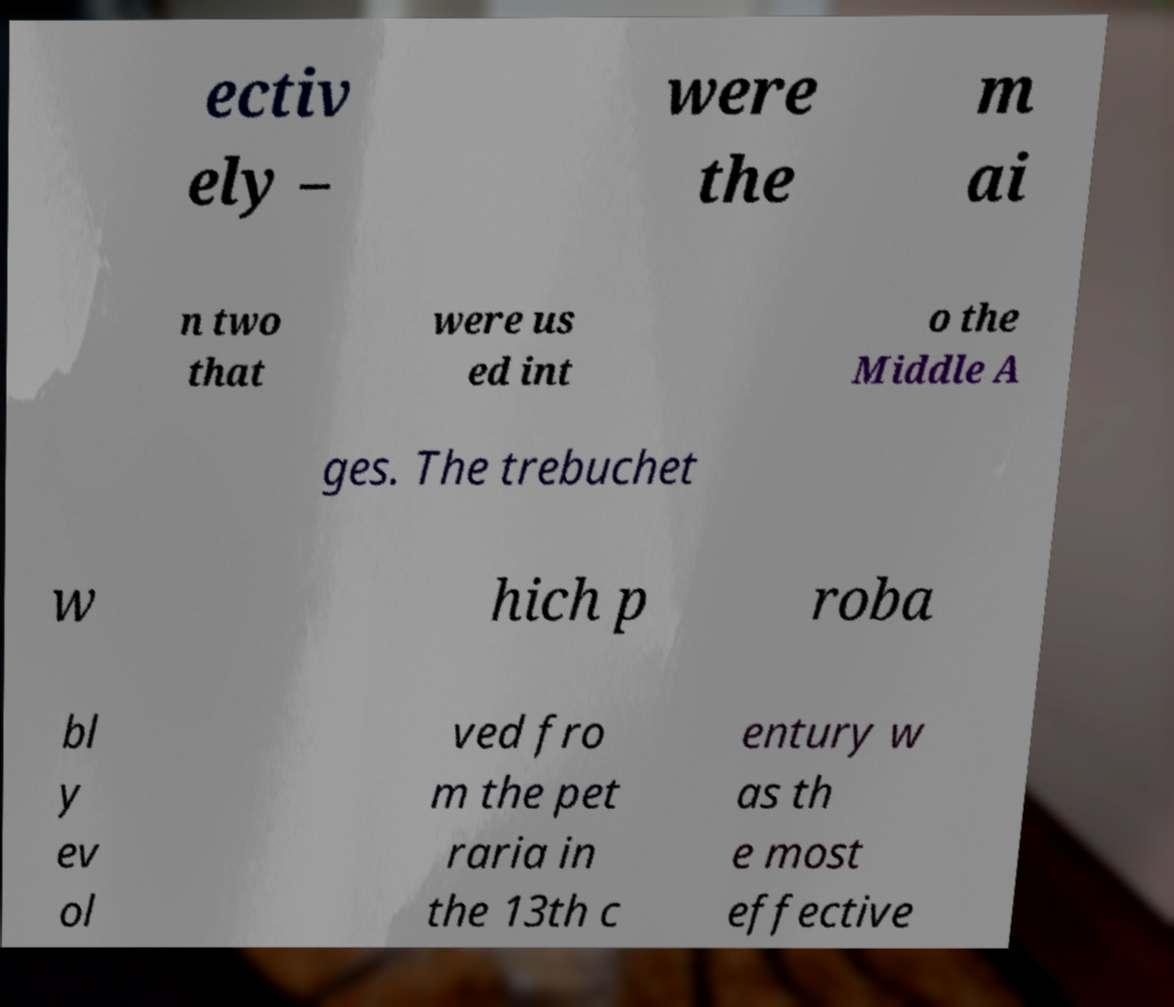Can you read and provide the text displayed in the image?This photo seems to have some interesting text. Can you extract and type it out for me? ectiv ely – were the m ai n two that were us ed int o the Middle A ges. The trebuchet w hich p roba bl y ev ol ved fro m the pet raria in the 13th c entury w as th e most effective 